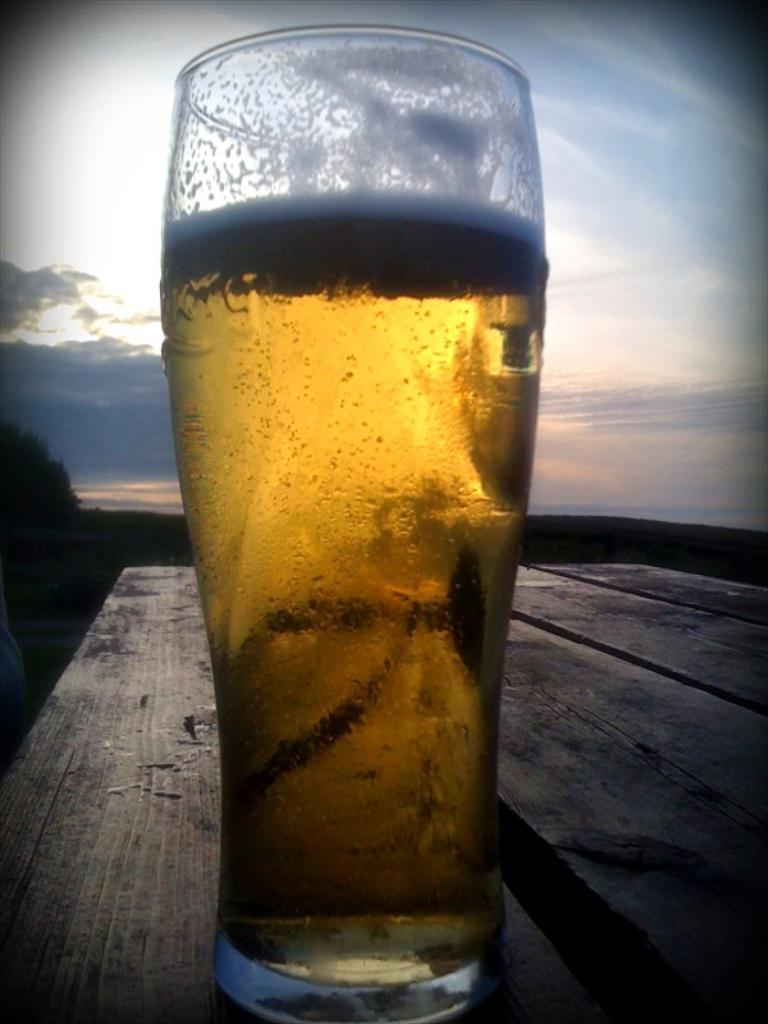What is in the glass that is visible in the image? There is a drink in the glass that is visible in the image. Where is the glass placed in the image? The glass is placed on a wooden table in the image. What can be seen in the background of the image? There are clouds in the background of the image. What is the color of the sky in the image? The sky is blue in the image. Is the maid having trouble with the wind in the image? There is no maid or any indication of trouble or wind present in the image. 